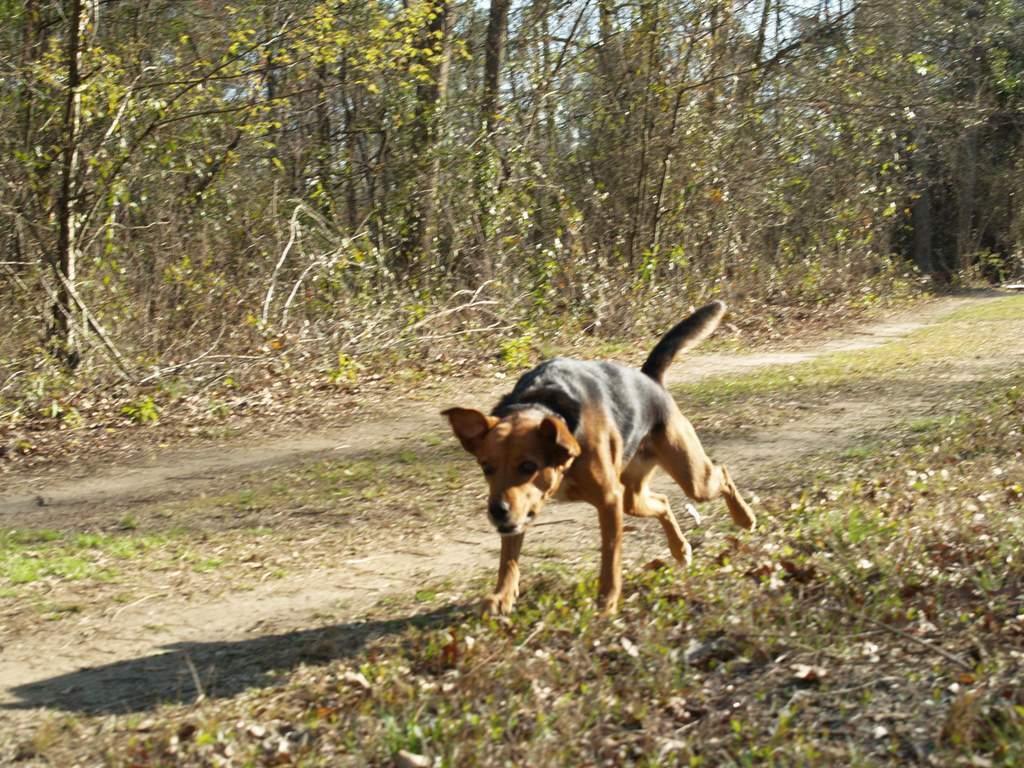What is the main subject of the image? There is a dog in the center of the image. Where is the dog located? The dog is on the ground. What can be seen in the background of the image? There are trees in the background of the image. What type of sponge can be seen floating in the water in the image? There is no water or sponge present in the image; it features a dog on the ground with trees in the background. 